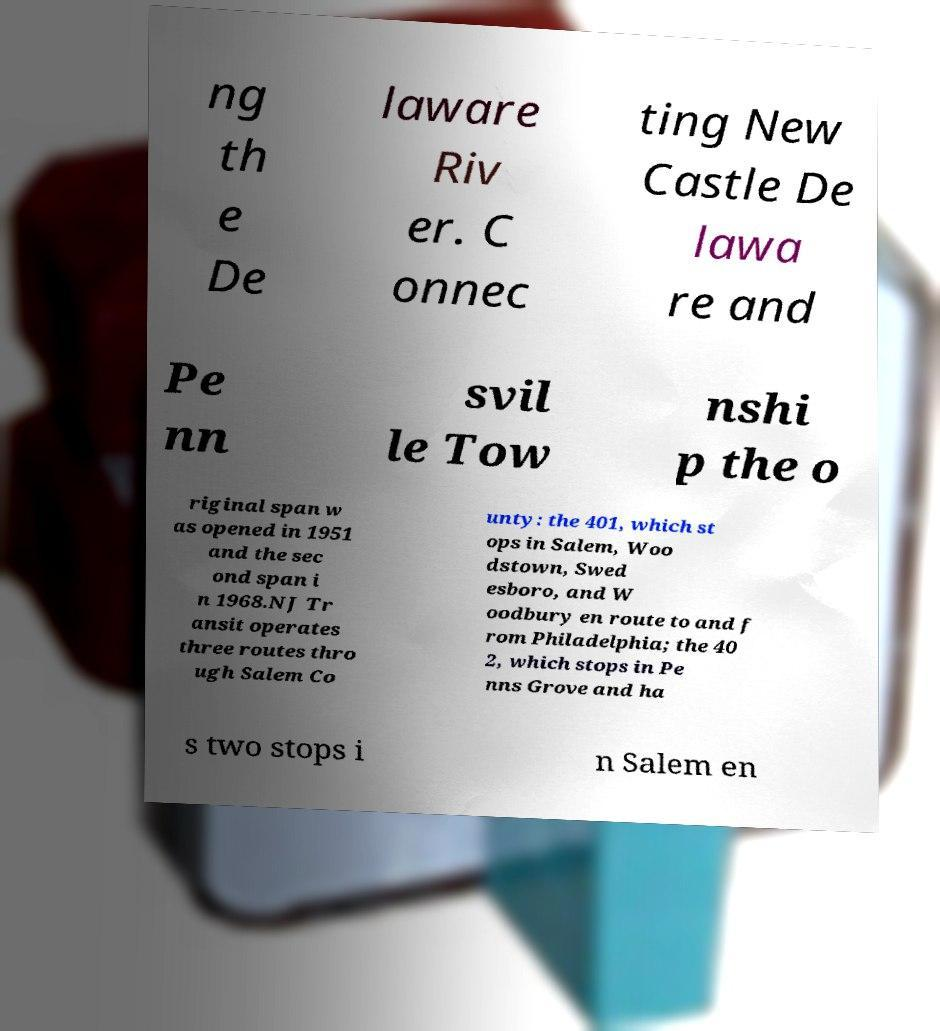For documentation purposes, I need the text within this image transcribed. Could you provide that? ng th e De laware Riv er. C onnec ting New Castle De lawa re and Pe nn svil le Tow nshi p the o riginal span w as opened in 1951 and the sec ond span i n 1968.NJ Tr ansit operates three routes thro ugh Salem Co unty: the 401, which st ops in Salem, Woo dstown, Swed esboro, and W oodbury en route to and f rom Philadelphia; the 40 2, which stops in Pe nns Grove and ha s two stops i n Salem en 